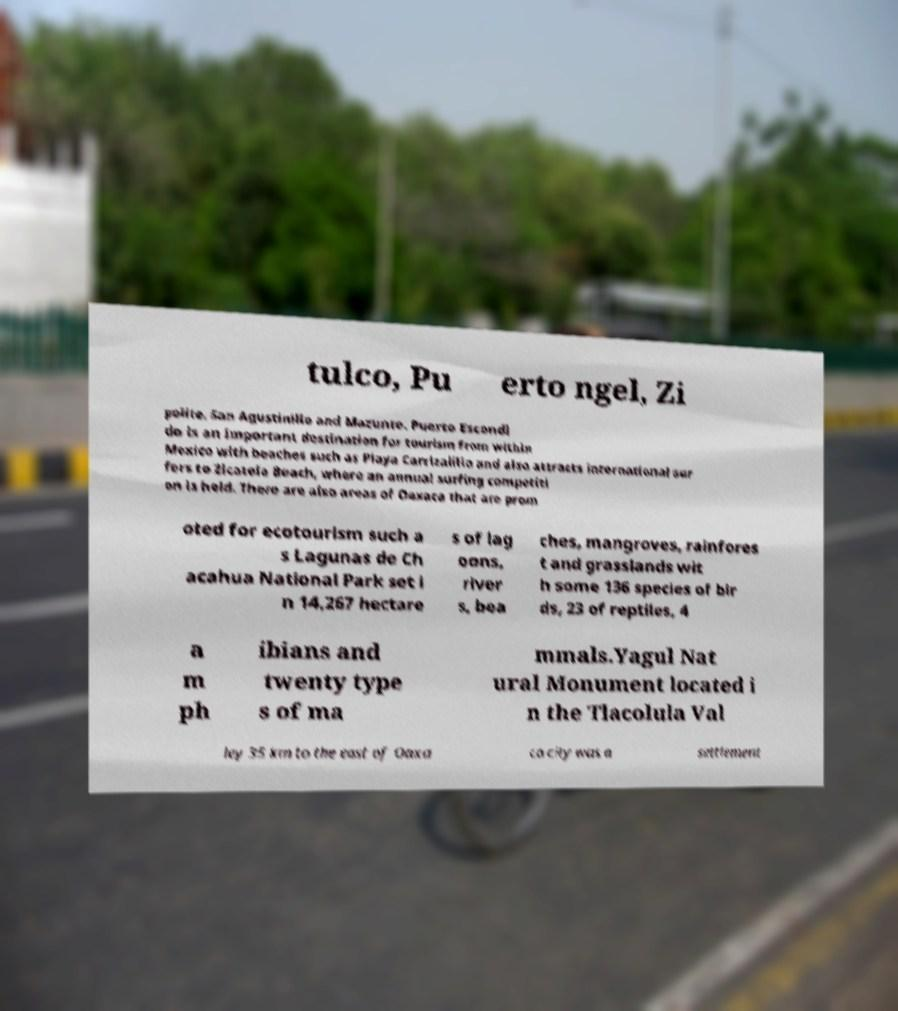Please identify and transcribe the text found in this image. tulco, Pu erto ngel, Zi polite, San Agustinillo and Mazunte. Puerto Escondi do is an important destination for tourism from within Mexico with beaches such as Playa Carrizalillo and also attracts international sur fers to Zicatela Beach, where an annual surfing competiti on is held. There are also areas of Oaxaca that are prom oted for ecotourism such a s Lagunas de Ch acahua National Park set i n 14,267 hectare s of lag oons, river s, bea ches, mangroves, rainfores t and grasslands wit h some 136 species of bir ds, 23 of reptiles, 4 a m ph ibians and twenty type s of ma mmals.Yagul Nat ural Monument located i n the Tlacolula Val ley 35 km to the east of Oaxa ca city was a settlement 